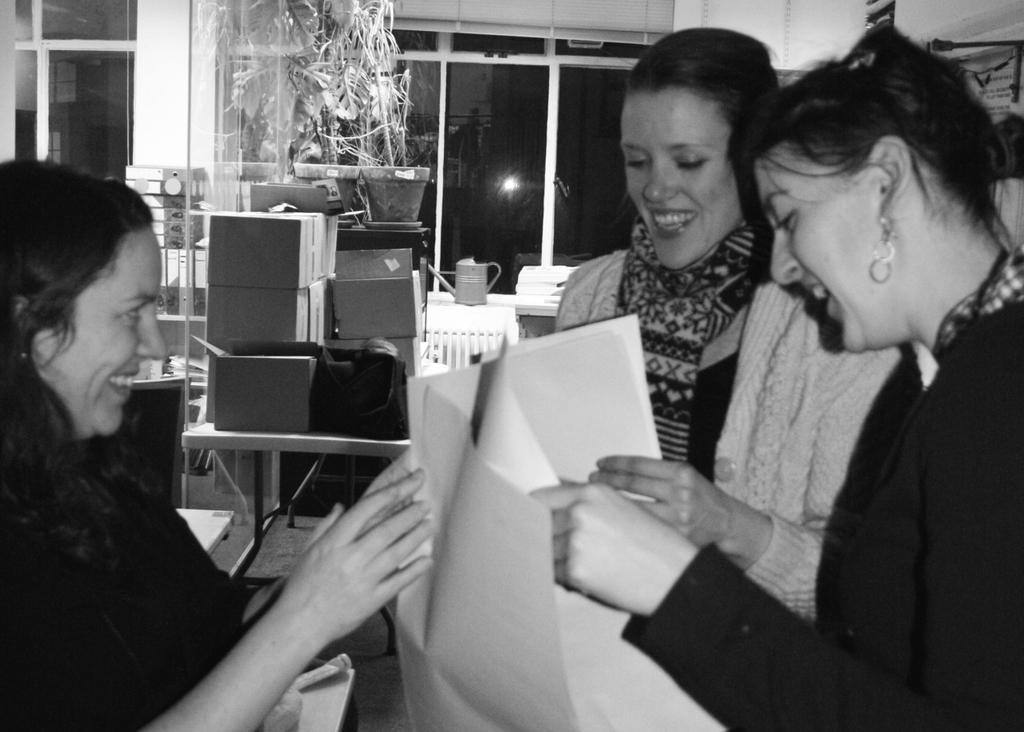How would you summarize this image in a sentence or two? In the image there are three women in the foreground, they are holding some papers and behind them there are some boxes, plants, a watering jug and in the background there are windows. 